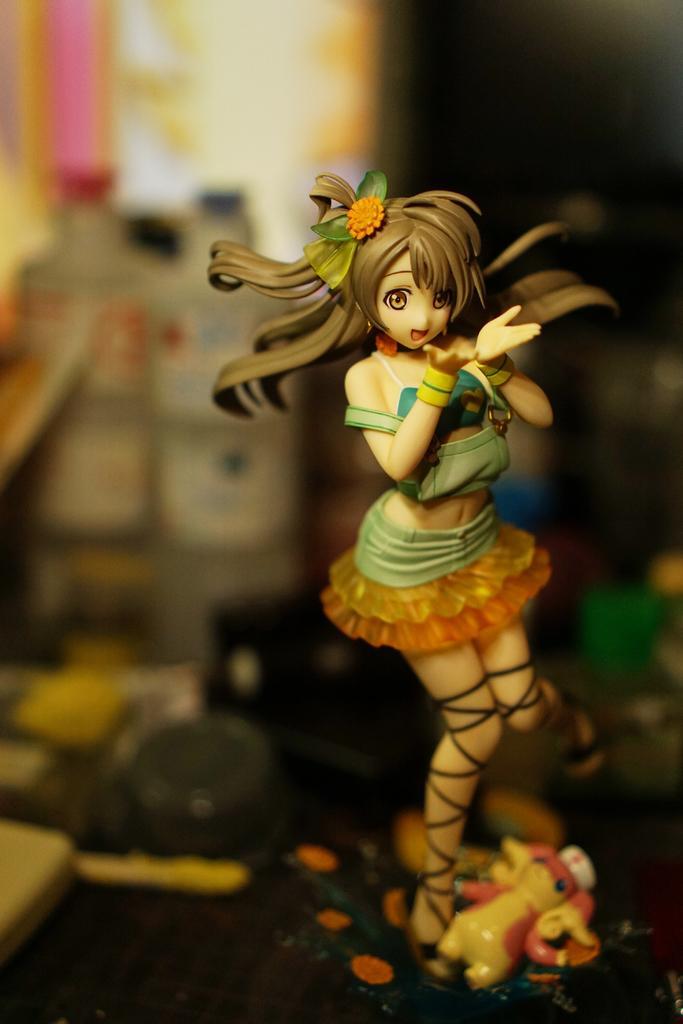How would you summarize this image in a sentence or two? In this image we can see a doll. In the background there are bottles. At the bottom there are toys. 